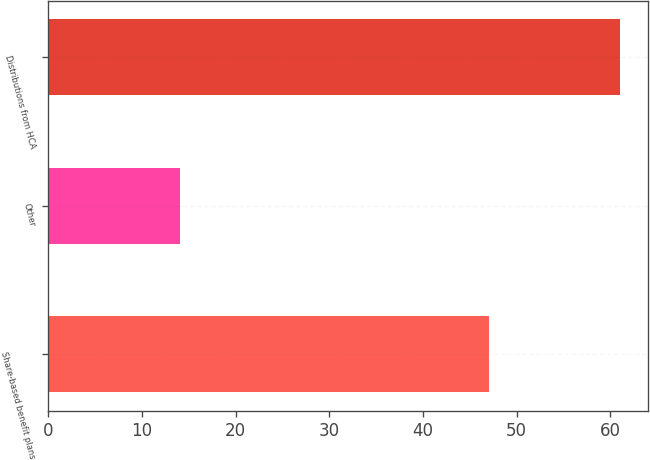Convert chart to OTSL. <chart><loc_0><loc_0><loc_500><loc_500><bar_chart><fcel>Share-based benefit plans<fcel>Other<fcel>Distributions from HCA<nl><fcel>47<fcel>14<fcel>61<nl></chart> 